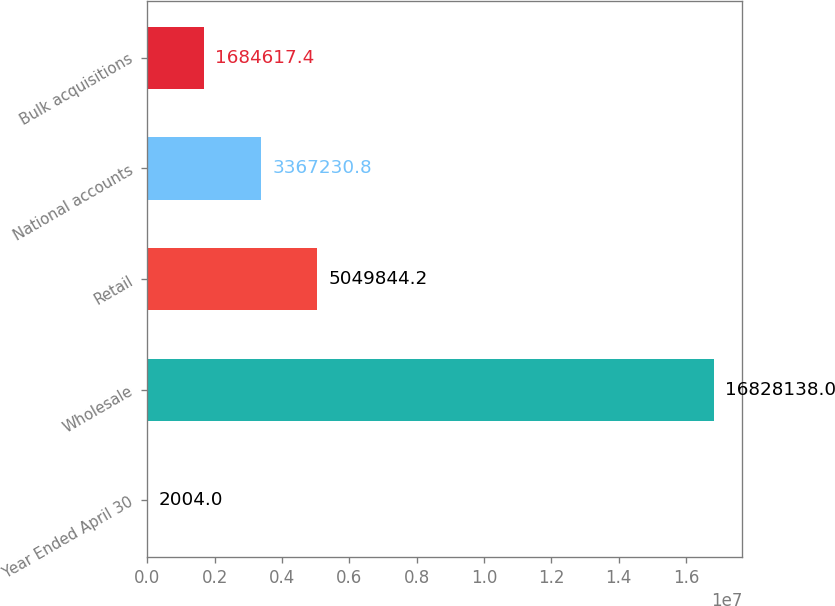Convert chart to OTSL. <chart><loc_0><loc_0><loc_500><loc_500><bar_chart><fcel>Year Ended April 30<fcel>Wholesale<fcel>Retail<fcel>National accounts<fcel>Bulk acquisitions<nl><fcel>2004<fcel>1.68281e+07<fcel>5.04984e+06<fcel>3.36723e+06<fcel>1.68462e+06<nl></chart> 